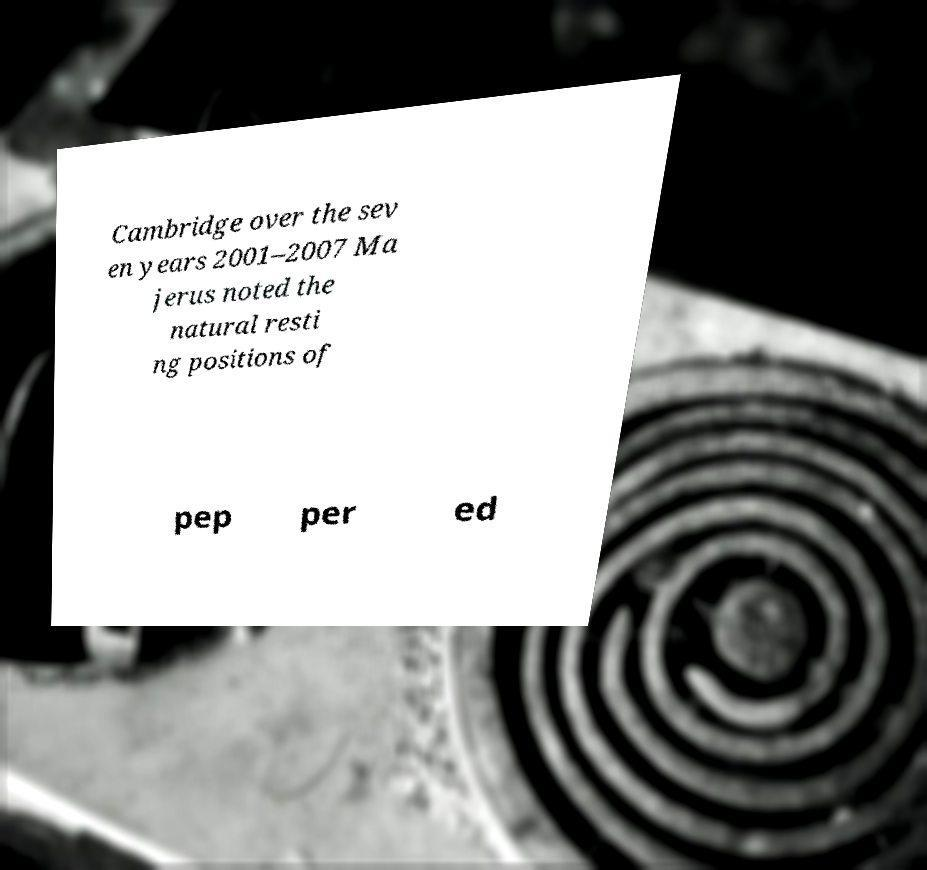I need the written content from this picture converted into text. Can you do that? Cambridge over the sev en years 2001–2007 Ma jerus noted the natural resti ng positions of pep per ed 